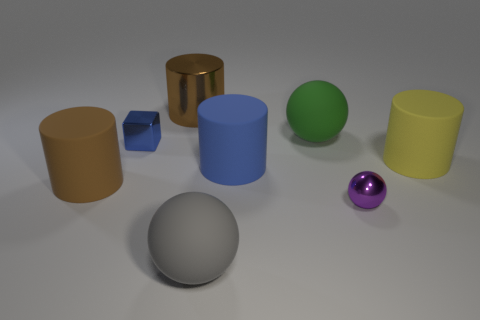Subtract all purple cylinders. Subtract all blue spheres. How many cylinders are left? 4 Add 1 small brown rubber cylinders. How many objects exist? 9 Subtract all spheres. How many objects are left? 5 Subtract all brown metal things. Subtract all gray matte things. How many objects are left? 6 Add 7 large rubber balls. How many large rubber balls are left? 9 Add 1 gray rubber objects. How many gray rubber objects exist? 2 Subtract 0 cyan blocks. How many objects are left? 8 